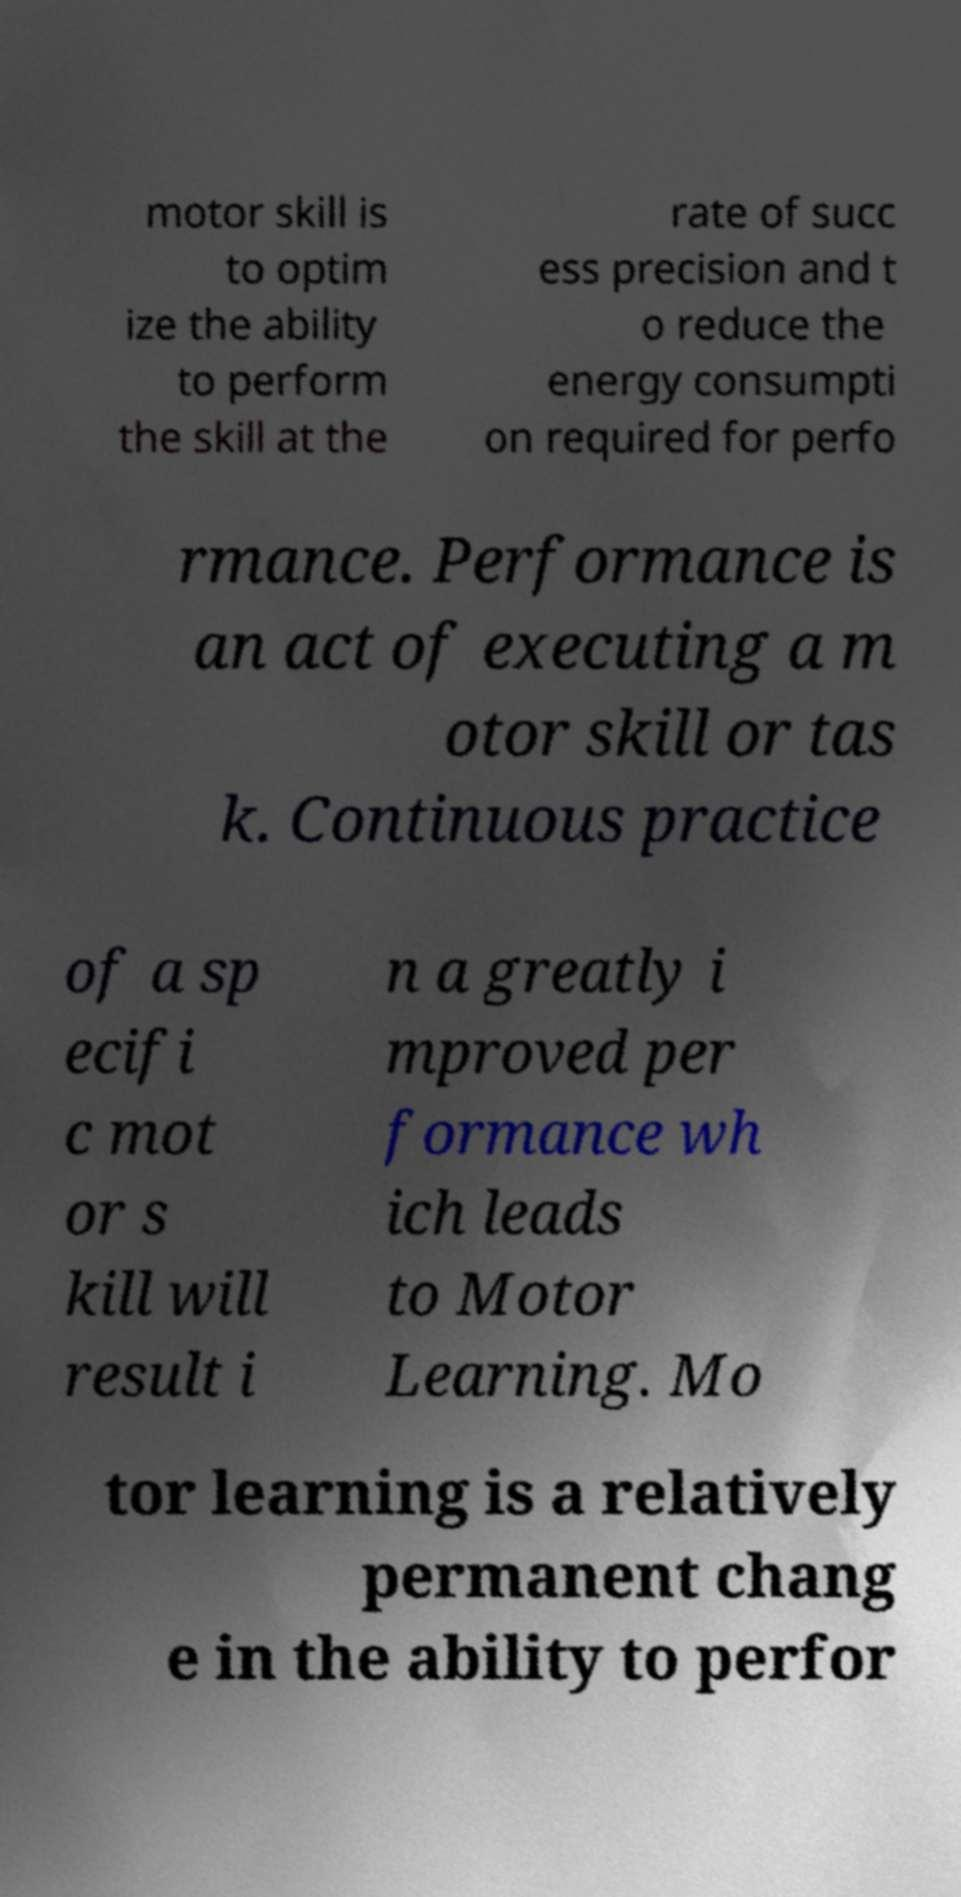Please read and relay the text visible in this image. What does it say? motor skill is to optim ize the ability to perform the skill at the rate of succ ess precision and t o reduce the energy consumpti on required for perfo rmance. Performance is an act of executing a m otor skill or tas k. Continuous practice of a sp ecifi c mot or s kill will result i n a greatly i mproved per formance wh ich leads to Motor Learning. Mo tor learning is a relatively permanent chang e in the ability to perfor 